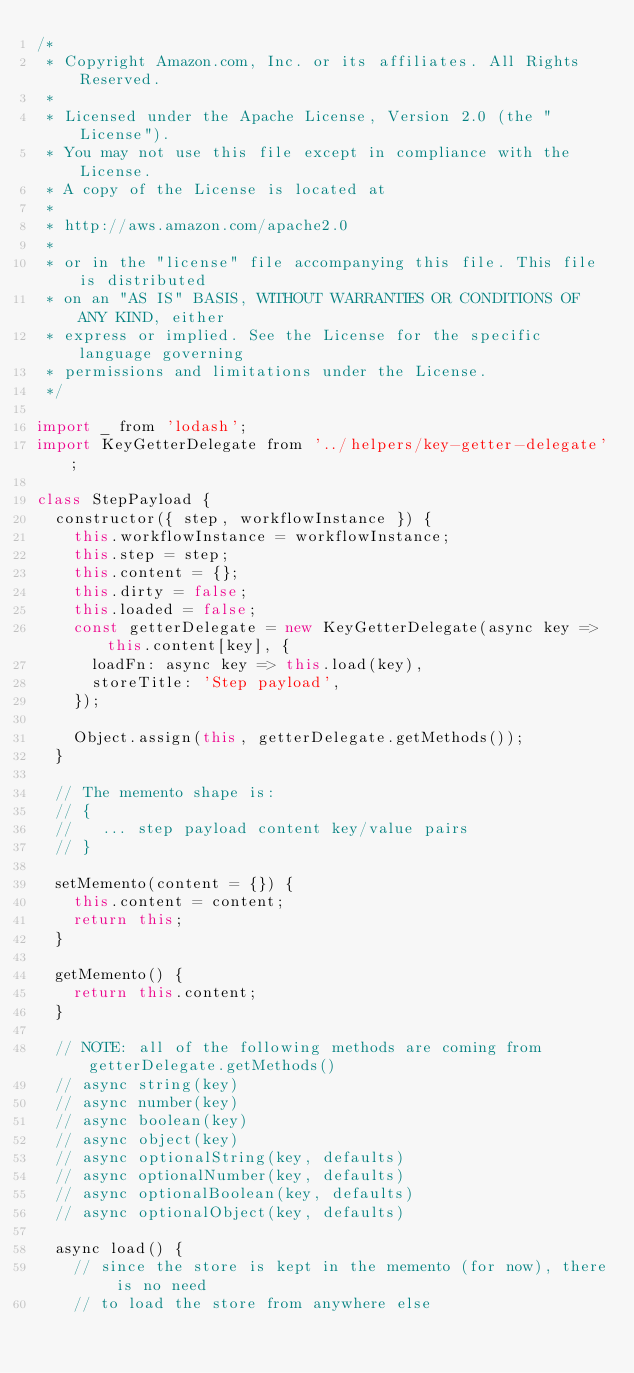<code> <loc_0><loc_0><loc_500><loc_500><_JavaScript_>/*
 * Copyright Amazon.com, Inc. or its affiliates. All Rights Reserved.
 *
 * Licensed under the Apache License, Version 2.0 (the "License").
 * You may not use this file except in compliance with the License.
 * A copy of the License is located at
 *
 * http://aws.amazon.com/apache2.0
 *
 * or in the "license" file accompanying this file. This file is distributed
 * on an "AS IS" BASIS, WITHOUT WARRANTIES OR CONDITIONS OF ANY KIND, either
 * express or implied. See the License for the specific language governing
 * permissions and limitations under the License.
 */

import _ from 'lodash';
import KeyGetterDelegate from '../helpers/key-getter-delegate';

class StepPayload {
  constructor({ step, workflowInstance }) {
    this.workflowInstance = workflowInstance;
    this.step = step;
    this.content = {};
    this.dirty = false;
    this.loaded = false;
    const getterDelegate = new KeyGetterDelegate(async key => this.content[key], {
      loadFn: async key => this.load(key),
      storeTitle: 'Step payload',
    });

    Object.assign(this, getterDelegate.getMethods());
  }

  // The memento shape is:
  // {
  //   ... step payload content key/value pairs
  // }

  setMemento(content = {}) {
    this.content = content;
    return this;
  }

  getMemento() {
    return this.content;
  }

  // NOTE: all of the following methods are coming from getterDelegate.getMethods()
  // async string(key)
  // async number(key)
  // async boolean(key)
  // async object(key)
  // async optionalString(key, defaults)
  // async optionalNumber(key, defaults)
  // async optionalBoolean(key, defaults)
  // async optionalObject(key, defaults)

  async load() {
    // since the store is kept in the memento (for now), there is no need
    // to load the store from anywhere else</code> 